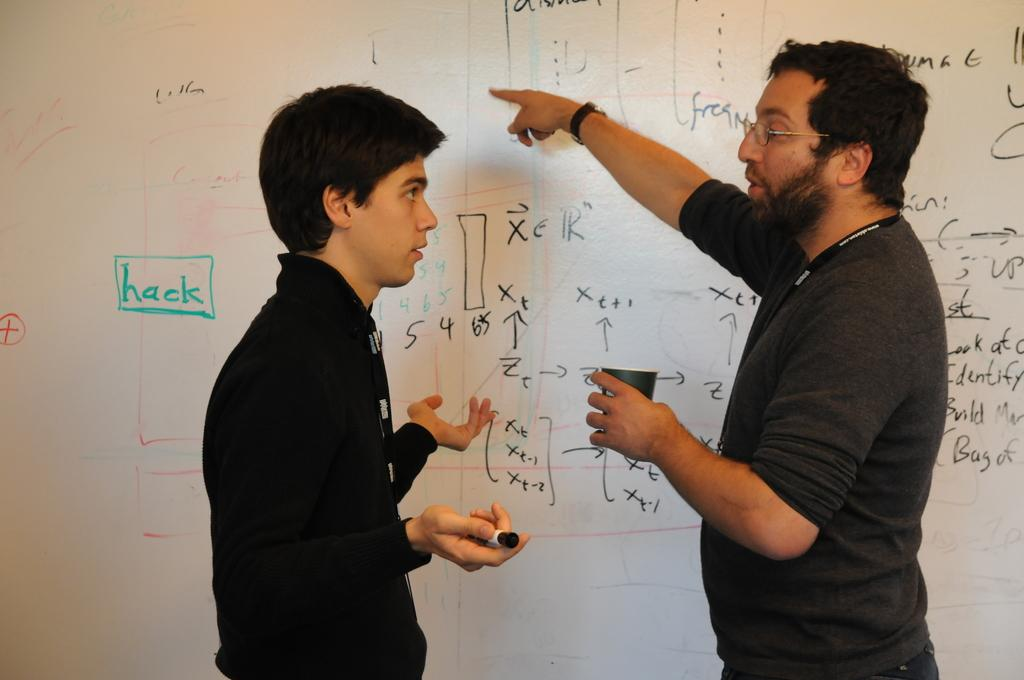<image>
Render a clear and concise summary of the photo. A man explains the equations on the whiteboard to a student and the word hack is written in green. 